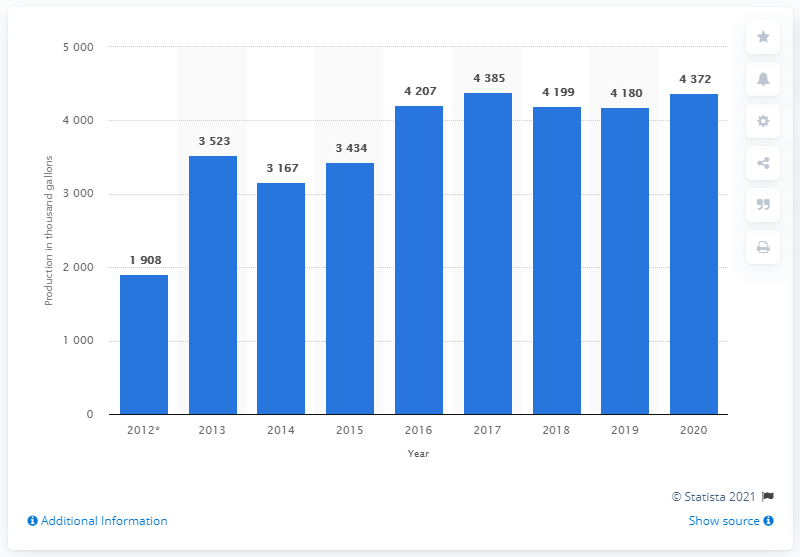Give some essential details in this illustration. The United States produced 43,720 metric tons of maple syrup in 2020. 